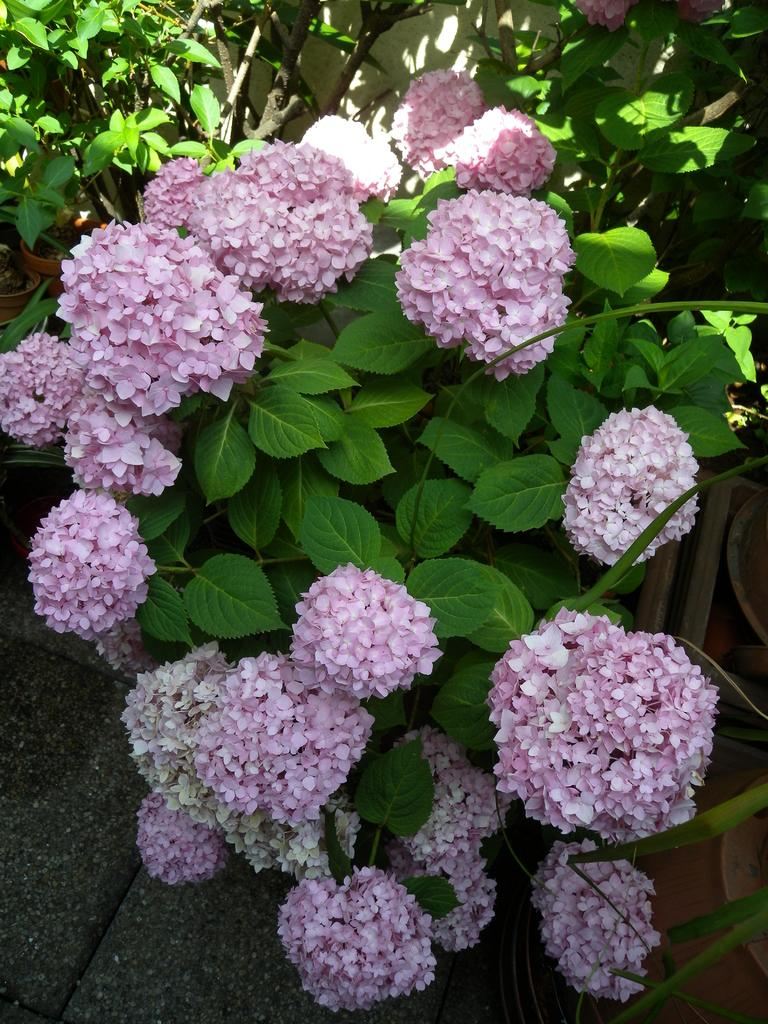What types of plants are in the center of the image? There are flowers and leaves in the center of the image. What is visible at the bottom of the image? There is ground visible at the bottom of the image. What type of apple can be seen growing on the flowers in the image? There are no apples present in the image, as it features flowers and leaves. Can you tell me how many family members are visible in the image? There are no family members present in the image; it features flowers and leaves. 